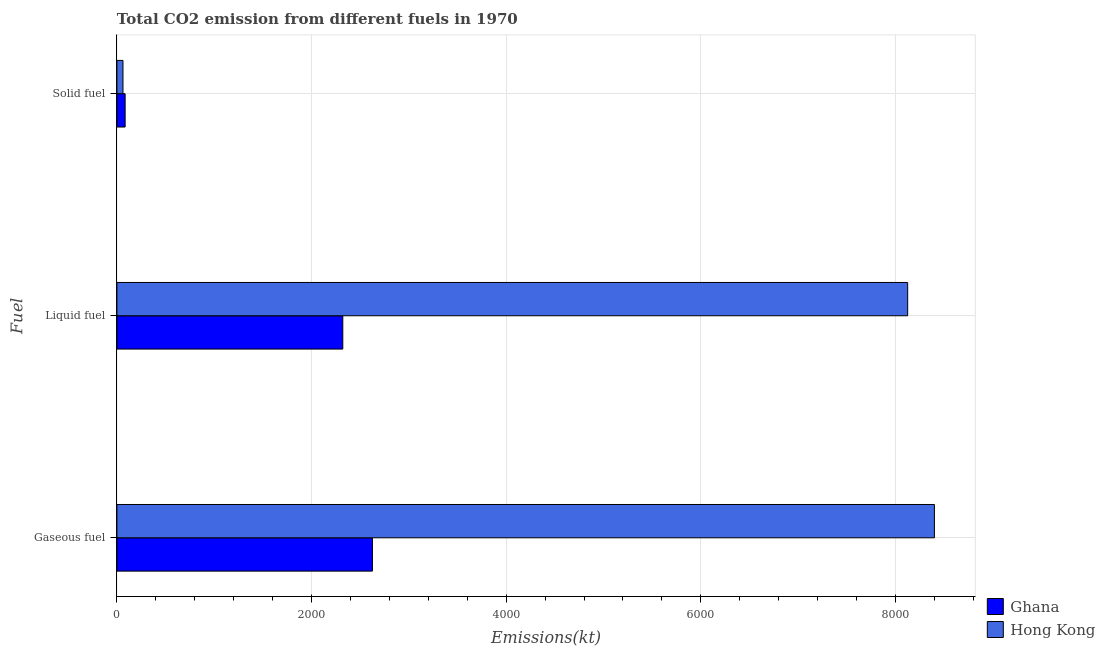How many different coloured bars are there?
Give a very brief answer. 2. Are the number of bars on each tick of the Y-axis equal?
Provide a short and direct response. Yes. How many bars are there on the 2nd tick from the bottom?
Offer a terse response. 2. What is the label of the 3rd group of bars from the top?
Ensure brevity in your answer.  Gaseous fuel. What is the amount of co2 emissions from gaseous fuel in Hong Kong?
Give a very brief answer. 8401.1. Across all countries, what is the maximum amount of co2 emissions from gaseous fuel?
Offer a very short reply. 8401.1. Across all countries, what is the minimum amount of co2 emissions from gaseous fuel?
Your answer should be very brief. 2625.57. In which country was the amount of co2 emissions from liquid fuel minimum?
Ensure brevity in your answer.  Ghana. What is the total amount of co2 emissions from liquid fuel in the graph?
Offer a terse response. 1.04e+04. What is the difference between the amount of co2 emissions from gaseous fuel in Hong Kong and that in Ghana?
Your answer should be compact. 5775.52. What is the difference between the amount of co2 emissions from liquid fuel in Ghana and the amount of co2 emissions from solid fuel in Hong Kong?
Offer a very short reply. 2258.87. What is the average amount of co2 emissions from gaseous fuel per country?
Ensure brevity in your answer.  5513.33. What is the difference between the amount of co2 emissions from solid fuel and amount of co2 emissions from liquid fuel in Ghana?
Provide a short and direct response. -2236.87. What is the ratio of the amount of co2 emissions from gaseous fuel in Ghana to that in Hong Kong?
Ensure brevity in your answer.  0.31. Is the amount of co2 emissions from gaseous fuel in Ghana less than that in Hong Kong?
Your response must be concise. Yes. Is the difference between the amount of co2 emissions from gaseous fuel in Hong Kong and Ghana greater than the difference between the amount of co2 emissions from liquid fuel in Hong Kong and Ghana?
Offer a very short reply. No. What is the difference between the highest and the second highest amount of co2 emissions from solid fuel?
Your answer should be very brief. 22. What is the difference between the highest and the lowest amount of co2 emissions from gaseous fuel?
Provide a succinct answer. 5775.52. In how many countries, is the amount of co2 emissions from liquid fuel greater than the average amount of co2 emissions from liquid fuel taken over all countries?
Make the answer very short. 1. What does the 2nd bar from the top in Liquid fuel represents?
Your response must be concise. Ghana. What is the difference between two consecutive major ticks on the X-axis?
Your answer should be very brief. 2000. Does the graph contain any zero values?
Your answer should be compact. No. Does the graph contain grids?
Make the answer very short. Yes. Where does the legend appear in the graph?
Ensure brevity in your answer.  Bottom right. What is the title of the graph?
Give a very brief answer. Total CO2 emission from different fuels in 1970. Does "Sao Tome and Principe" appear as one of the legend labels in the graph?
Provide a succinct answer. No. What is the label or title of the X-axis?
Ensure brevity in your answer.  Emissions(kt). What is the label or title of the Y-axis?
Your answer should be very brief. Fuel. What is the Emissions(kt) in Ghana in Gaseous fuel?
Keep it short and to the point. 2625.57. What is the Emissions(kt) of Hong Kong in Gaseous fuel?
Provide a succinct answer. 8401.1. What is the Emissions(kt) in Ghana in Liquid fuel?
Provide a short and direct response. 2321.21. What is the Emissions(kt) of Hong Kong in Liquid fuel?
Give a very brief answer. 8126.07. What is the Emissions(kt) of Ghana in Solid fuel?
Your answer should be compact. 84.34. What is the Emissions(kt) in Hong Kong in Solid fuel?
Your response must be concise. 62.34. Across all Fuel, what is the maximum Emissions(kt) of Ghana?
Your answer should be compact. 2625.57. Across all Fuel, what is the maximum Emissions(kt) in Hong Kong?
Offer a very short reply. 8401.1. Across all Fuel, what is the minimum Emissions(kt) of Ghana?
Give a very brief answer. 84.34. Across all Fuel, what is the minimum Emissions(kt) of Hong Kong?
Provide a succinct answer. 62.34. What is the total Emissions(kt) in Ghana in the graph?
Provide a short and direct response. 5031.12. What is the total Emissions(kt) of Hong Kong in the graph?
Offer a terse response. 1.66e+04. What is the difference between the Emissions(kt) of Ghana in Gaseous fuel and that in Liquid fuel?
Provide a succinct answer. 304.36. What is the difference between the Emissions(kt) of Hong Kong in Gaseous fuel and that in Liquid fuel?
Make the answer very short. 275.02. What is the difference between the Emissions(kt) of Ghana in Gaseous fuel and that in Solid fuel?
Provide a short and direct response. 2541.23. What is the difference between the Emissions(kt) of Hong Kong in Gaseous fuel and that in Solid fuel?
Make the answer very short. 8338.76. What is the difference between the Emissions(kt) in Ghana in Liquid fuel and that in Solid fuel?
Give a very brief answer. 2236.87. What is the difference between the Emissions(kt) in Hong Kong in Liquid fuel and that in Solid fuel?
Your answer should be very brief. 8063.73. What is the difference between the Emissions(kt) of Ghana in Gaseous fuel and the Emissions(kt) of Hong Kong in Liquid fuel?
Offer a terse response. -5500.5. What is the difference between the Emissions(kt) in Ghana in Gaseous fuel and the Emissions(kt) in Hong Kong in Solid fuel?
Offer a terse response. 2563.23. What is the difference between the Emissions(kt) of Ghana in Liquid fuel and the Emissions(kt) of Hong Kong in Solid fuel?
Offer a terse response. 2258.87. What is the average Emissions(kt) in Ghana per Fuel?
Your answer should be very brief. 1677.04. What is the average Emissions(kt) in Hong Kong per Fuel?
Make the answer very short. 5529.84. What is the difference between the Emissions(kt) in Ghana and Emissions(kt) in Hong Kong in Gaseous fuel?
Make the answer very short. -5775.52. What is the difference between the Emissions(kt) of Ghana and Emissions(kt) of Hong Kong in Liquid fuel?
Your answer should be compact. -5804.86. What is the difference between the Emissions(kt) of Ghana and Emissions(kt) of Hong Kong in Solid fuel?
Ensure brevity in your answer.  22. What is the ratio of the Emissions(kt) in Ghana in Gaseous fuel to that in Liquid fuel?
Provide a short and direct response. 1.13. What is the ratio of the Emissions(kt) of Hong Kong in Gaseous fuel to that in Liquid fuel?
Your response must be concise. 1.03. What is the ratio of the Emissions(kt) of Ghana in Gaseous fuel to that in Solid fuel?
Your response must be concise. 31.13. What is the ratio of the Emissions(kt) of Hong Kong in Gaseous fuel to that in Solid fuel?
Keep it short and to the point. 134.76. What is the ratio of the Emissions(kt) in Ghana in Liquid fuel to that in Solid fuel?
Offer a very short reply. 27.52. What is the ratio of the Emissions(kt) of Hong Kong in Liquid fuel to that in Solid fuel?
Offer a very short reply. 130.35. What is the difference between the highest and the second highest Emissions(kt) of Ghana?
Offer a very short reply. 304.36. What is the difference between the highest and the second highest Emissions(kt) of Hong Kong?
Your response must be concise. 275.02. What is the difference between the highest and the lowest Emissions(kt) in Ghana?
Provide a short and direct response. 2541.23. What is the difference between the highest and the lowest Emissions(kt) of Hong Kong?
Your answer should be compact. 8338.76. 